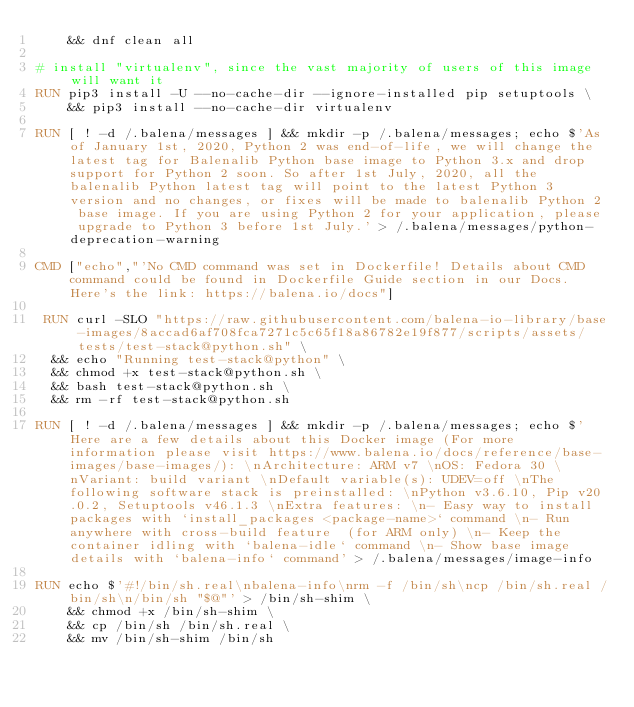Convert code to text. <code><loc_0><loc_0><loc_500><loc_500><_Dockerfile_>	&& dnf clean all

# install "virtualenv", since the vast majority of users of this image will want it
RUN pip3 install -U --no-cache-dir --ignore-installed pip setuptools \
	&& pip3 install --no-cache-dir virtualenv

RUN [ ! -d /.balena/messages ] && mkdir -p /.balena/messages; echo $'As of January 1st, 2020, Python 2 was end-of-life, we will change the latest tag for Balenalib Python base image to Python 3.x and drop support for Python 2 soon. So after 1st July, 2020, all the balenalib Python latest tag will point to the latest Python 3 version and no changes, or fixes will be made to balenalib Python 2 base image. If you are using Python 2 for your application, please upgrade to Python 3 before 1st July.' > /.balena/messages/python-deprecation-warning

CMD ["echo","'No CMD command was set in Dockerfile! Details about CMD command could be found in Dockerfile Guide section in our Docs. Here's the link: https://balena.io/docs"]

 RUN curl -SLO "https://raw.githubusercontent.com/balena-io-library/base-images/8accad6af708fca7271c5c65f18a86782e19f877/scripts/assets/tests/test-stack@python.sh" \
  && echo "Running test-stack@python" \
  && chmod +x test-stack@python.sh \
  && bash test-stack@python.sh \
  && rm -rf test-stack@python.sh 

RUN [ ! -d /.balena/messages ] && mkdir -p /.balena/messages; echo $'Here are a few details about this Docker image (For more information please visit https://www.balena.io/docs/reference/base-images/base-images/): \nArchitecture: ARM v7 \nOS: Fedora 30 \nVariant: build variant \nDefault variable(s): UDEV=off \nThe following software stack is preinstalled: \nPython v3.6.10, Pip v20.0.2, Setuptools v46.1.3 \nExtra features: \n- Easy way to install packages with `install_packages <package-name>` command \n- Run anywhere with cross-build feature  (for ARM only) \n- Keep the container idling with `balena-idle` command \n- Show base image details with `balena-info` command' > /.balena/messages/image-info

RUN echo $'#!/bin/sh.real\nbalena-info\nrm -f /bin/sh\ncp /bin/sh.real /bin/sh\n/bin/sh "$@"' > /bin/sh-shim \
	&& chmod +x /bin/sh-shim \
	&& cp /bin/sh /bin/sh.real \
	&& mv /bin/sh-shim /bin/sh</code> 